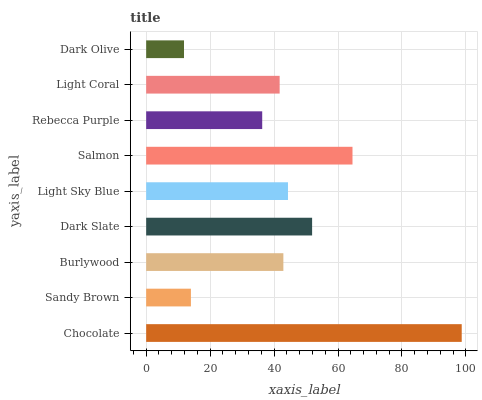Is Dark Olive the minimum?
Answer yes or no. Yes. Is Chocolate the maximum?
Answer yes or no. Yes. Is Sandy Brown the minimum?
Answer yes or no. No. Is Sandy Brown the maximum?
Answer yes or no. No. Is Chocolate greater than Sandy Brown?
Answer yes or no. Yes. Is Sandy Brown less than Chocolate?
Answer yes or no. Yes. Is Sandy Brown greater than Chocolate?
Answer yes or no. No. Is Chocolate less than Sandy Brown?
Answer yes or no. No. Is Burlywood the high median?
Answer yes or no. Yes. Is Burlywood the low median?
Answer yes or no. Yes. Is Light Coral the high median?
Answer yes or no. No. Is Sandy Brown the low median?
Answer yes or no. No. 